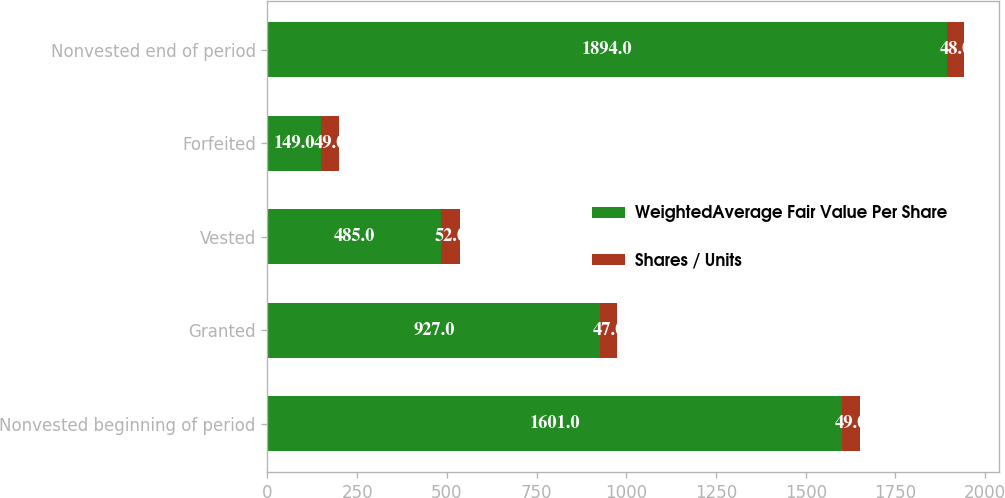Convert chart. <chart><loc_0><loc_0><loc_500><loc_500><stacked_bar_chart><ecel><fcel>Nonvested beginning of period<fcel>Granted<fcel>Vested<fcel>Forfeited<fcel>Nonvested end of period<nl><fcel>WeightedAverage Fair Value Per Share<fcel>1601<fcel>927<fcel>485<fcel>149<fcel>1894<nl><fcel>Shares / Units<fcel>49<fcel>47<fcel>52<fcel>49<fcel>48<nl></chart> 